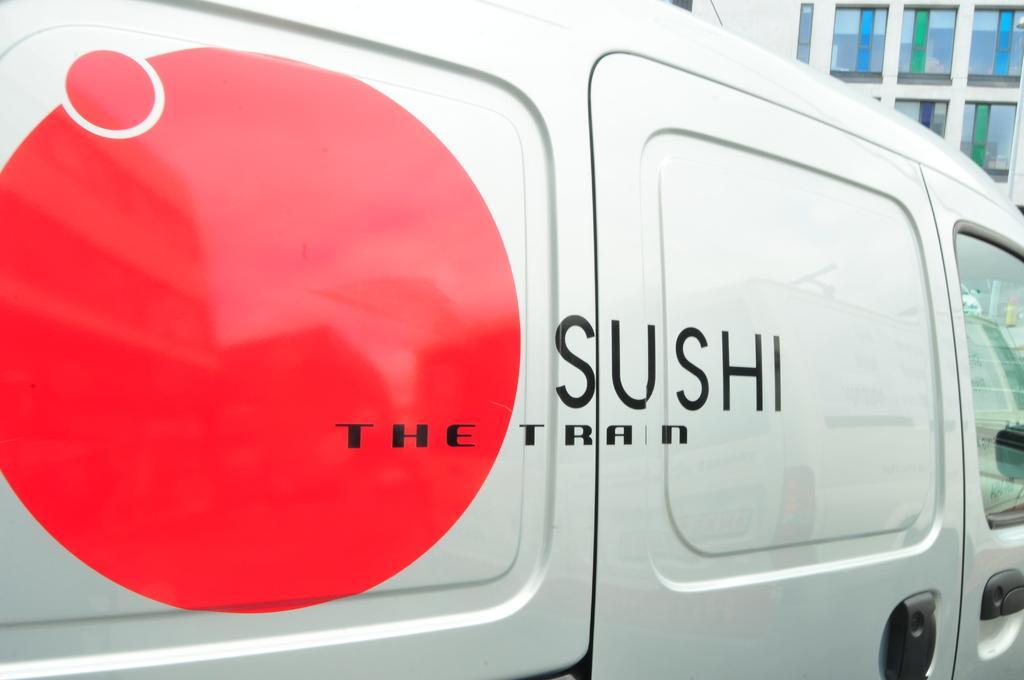Can you describe this image briefly? In this image I can see a vehicle which is white in color and red colored paint on it. In the background I can see the building. 